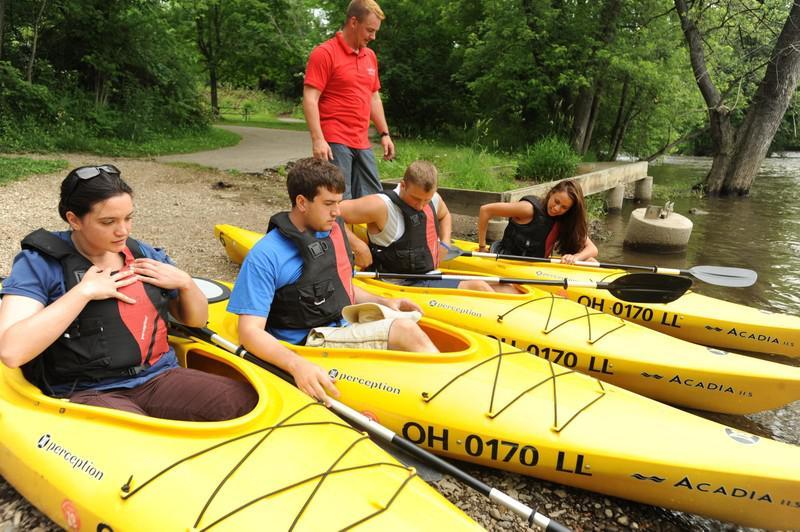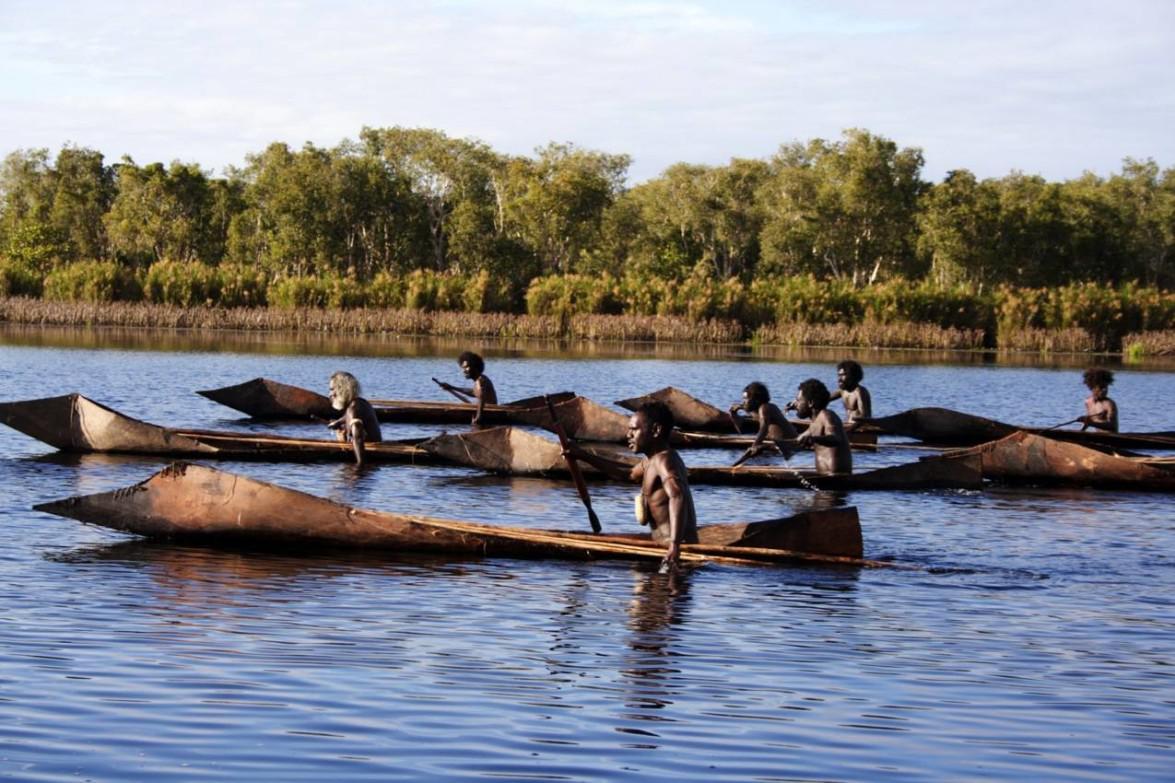The first image is the image on the left, the second image is the image on the right. Evaluate the accuracy of this statement regarding the images: "The right image contains exactly two side-by-side canoes which are on the water and angled forward.". Is it true? Answer yes or no. No. The first image is the image on the left, the second image is the image on the right. For the images displayed, is the sentence "There are exactly three canoes." factually correct? Answer yes or no. No. 